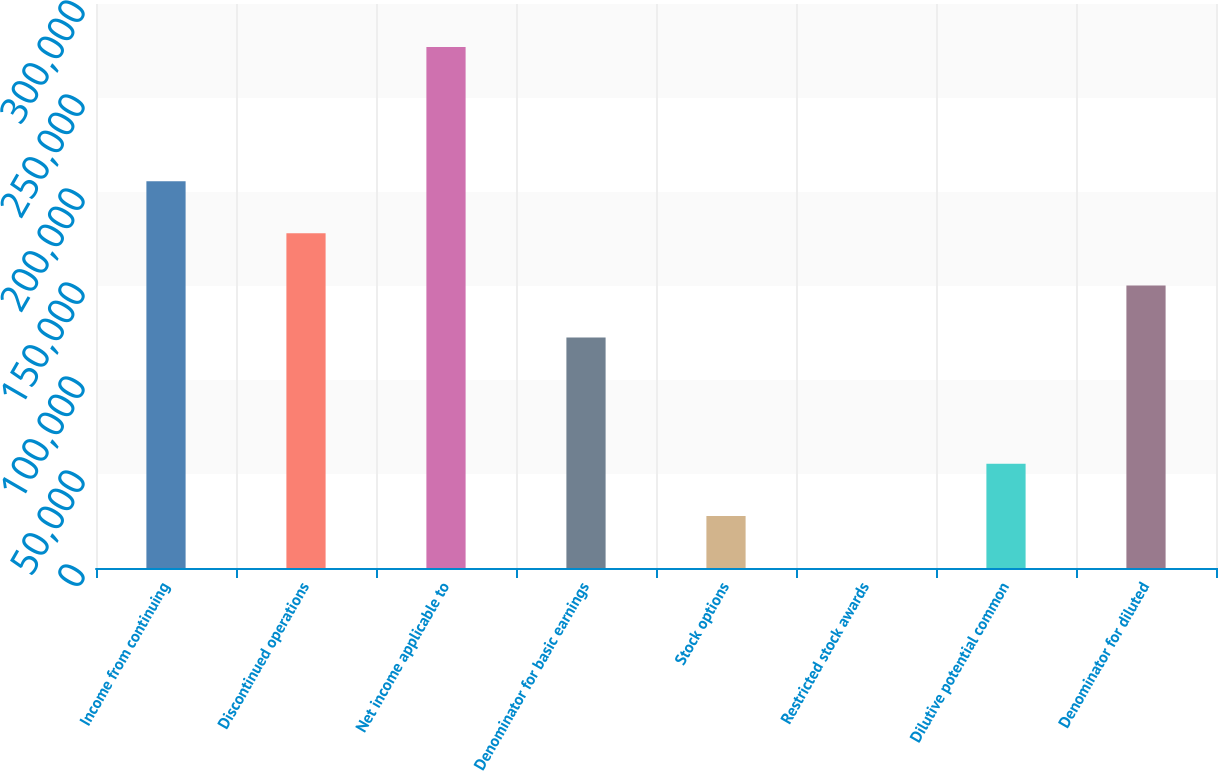Convert chart. <chart><loc_0><loc_0><loc_500><loc_500><bar_chart><fcel>Income from continuing<fcel>Discontinued operations<fcel>Net income applicable to<fcel>Denominator for basic earnings<fcel>Stock options<fcel>Restricted stock awards<fcel>Dilutive potential common<fcel>Denominator for diluted<nl><fcel>205728<fcel>178018<fcel>277119<fcel>122597<fcel>27724.5<fcel>14<fcel>55435<fcel>150308<nl></chart> 